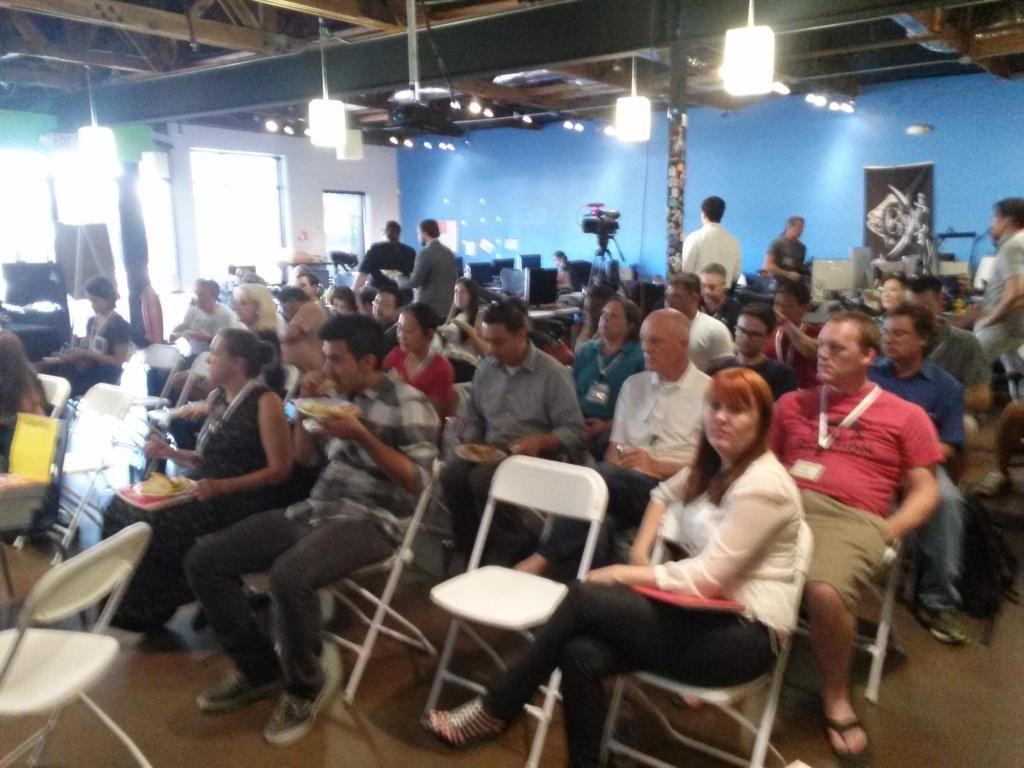Could you give a brief overview of what you see in this image? In this image i can see a group of people are sitting on a chair. I can also see there few lights and blue color wall. 